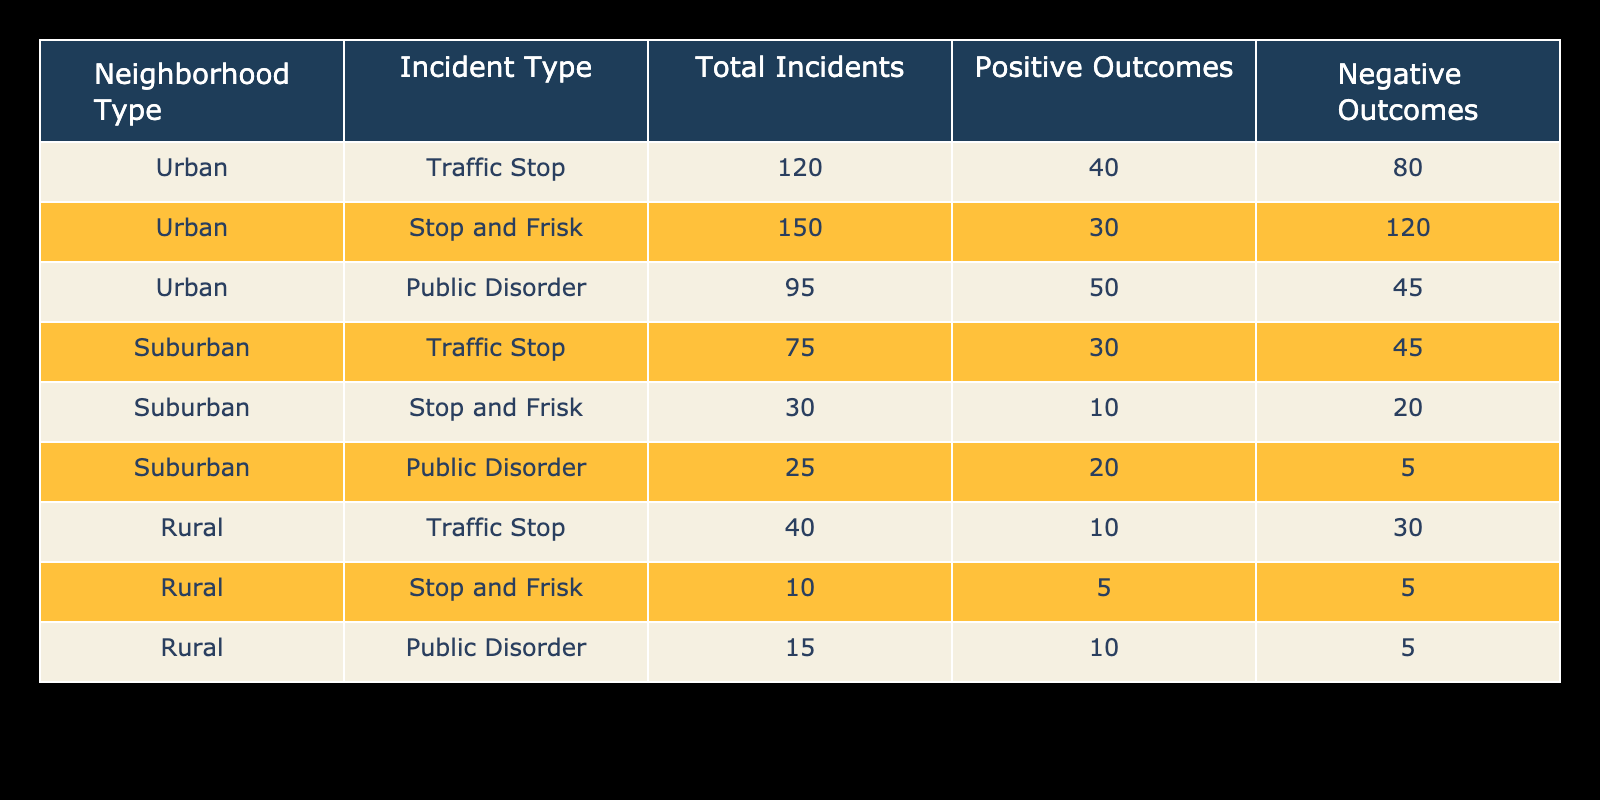What is the total number of traffic stop incidents reported in urban neighborhoods? The table shows that there are 120 reported traffic stop incidents in urban neighborhoods. This value is explicitly listed directly under the "Total Incidents" column for the "Traffic Stop" incident type in the "Urban" row.
Answer: 120 What is the outcome for the majority of stop and frisk incidents in suburban areas? For suburban stop and frisk incidents, there are a total of 30 incidents, with 10 positive outcomes and 20 negative outcomes. Since 20 is greater than 10, the majority of the stop and frisk incidents in suburban areas have negative outcomes.
Answer: Negative How many positive outcomes are reported in rural public disorder incidents? The table states that there are 15 incidents of public disorder reported in rural neighborhoods, with 10 of those being classified as positive outcomes. This is simply taken from the "Outcome Positive" column specific to the "Public Disorder" incident type in the "Rural" row.
Answer: 10 What is the ratio of positive outcomes to negative outcomes for urban incidents? For urban incidents, we can compute the total positive outcomes by adding up values from each incident type: 40 (Traffic Stop) + 30 (Stop and Frisk) + 50 (Public Disorder) = 120 positive outcomes. The total negative outcomes are: 80 (Traffic Stop) + 120 (Stop and Frisk) + 45 (Public Disorder) = 245 negative outcomes. Therefore, the ratio is 120:245, which reduces to approximately 24:49. This is a calculation using the outcomes of all incident types.
Answer: 24:49 Is there any type of incident in rural neighborhoods that has more positive outcomes than negative outcomes? Looking at the rural incidents: Traffic Stop has 10 positive and 30 negative, Stop and Frisk has 5 positive and 5 negative, and Public Disorder has 10 positive and 5 negative. The only incident with more positive outcomes than negative is Public Disorder, which has 10 positive and 5 negative. Thus, it is true that there is an incident type that meets this criterion.
Answer: Yes Which neighborhood type had the highest total incidents reported? To determine this, we add up the total incidents for each neighborhood type: Urban: 120 + 150 + 95 = 365; Suburban: 75 + 30 + 25 = 130; Rural: 40 + 10 + 15 = 65. Urban neighborhoods have the highest total of 365 incidents reported, compared to suburban and rural totals.
Answer: Urban What is the average number of total incidents for suburban neighborhoods? For suburban neighborhoods, we have three types of incidents: 75 (Traffic Stop), 30 (Stop and Frisk), and 25 (Public Disorder). We first sum them: 75 + 30 + 25 = 130. To find the average, we divide by the number of incident types, which is 3. Thus, 130 / 3 = 43.33. This mean value conveys the typical incident count across suburban areas.
Answer: 43.33 What percentage of public disorder incidents in urban neighborhoods had negative outcomes? The total public disorder incidents in urban areas number 95, with 45 classified as negative outcomes. To find the percentage, we calculate (45 / 95) * 100, which gives us approximately 47.37%. Thus, around 47 percent of public disorder incidents had negative outcomes in urban areas.
Answer: 47.37% 